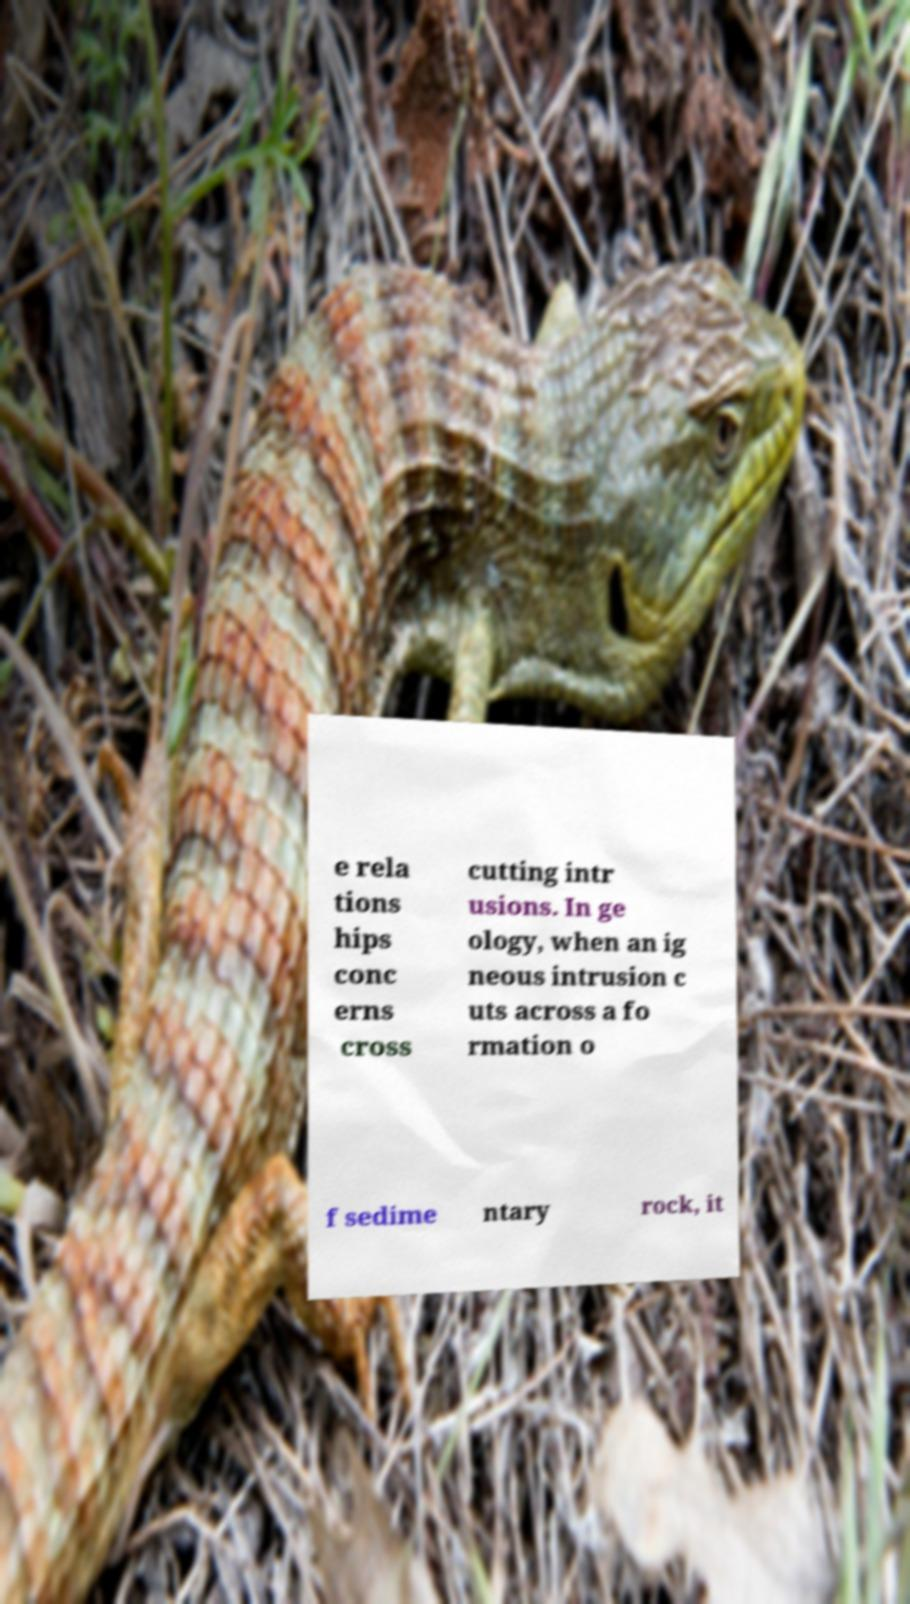There's text embedded in this image that I need extracted. Can you transcribe it verbatim? e rela tions hips conc erns cross cutting intr usions. In ge ology, when an ig neous intrusion c uts across a fo rmation o f sedime ntary rock, it 